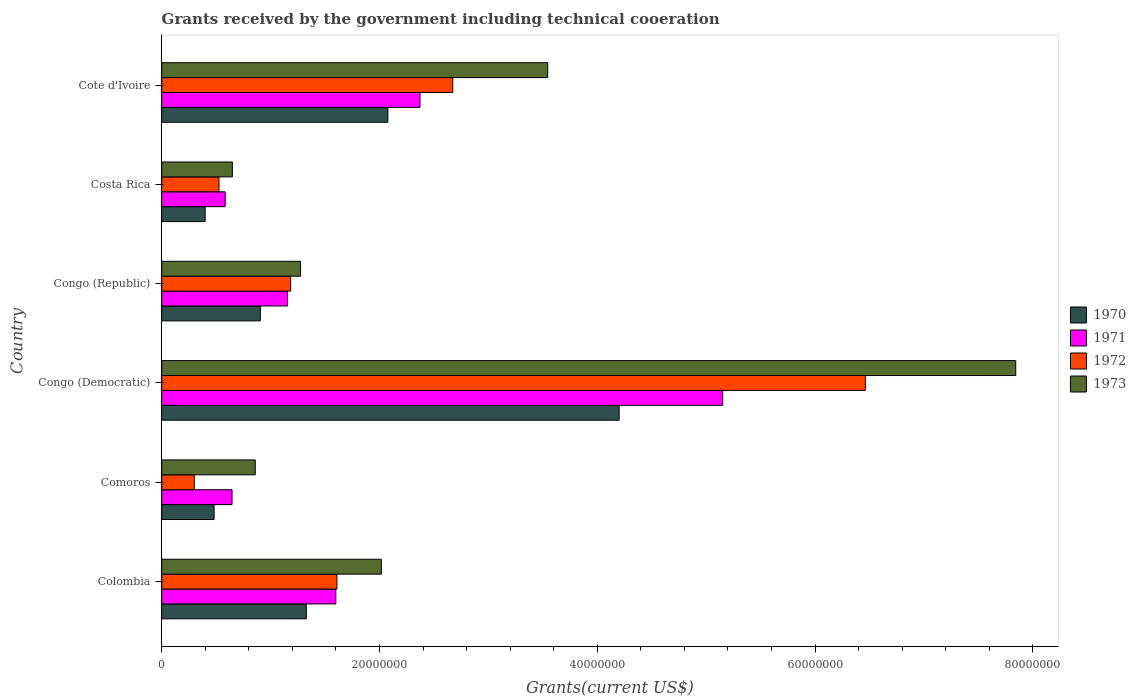How many groups of bars are there?
Keep it short and to the point. 6. How many bars are there on the 5th tick from the bottom?
Provide a short and direct response. 4. What is the label of the 5th group of bars from the top?
Ensure brevity in your answer.  Comoros. What is the total grants received by the government in 1971 in Congo (Republic)?
Provide a short and direct response. 1.16e+07. Across all countries, what is the maximum total grants received by the government in 1971?
Make the answer very short. 5.15e+07. Across all countries, what is the minimum total grants received by the government in 1972?
Make the answer very short. 2.99e+06. In which country was the total grants received by the government in 1970 maximum?
Ensure brevity in your answer.  Congo (Democratic). In which country was the total grants received by the government in 1970 minimum?
Offer a very short reply. Costa Rica. What is the total total grants received by the government in 1971 in the graph?
Your answer should be compact. 1.15e+08. What is the difference between the total grants received by the government in 1973 in Comoros and that in Cote d'Ivoire?
Provide a short and direct response. -2.69e+07. What is the difference between the total grants received by the government in 1972 in Comoros and the total grants received by the government in 1971 in Costa Rica?
Your answer should be compact. -2.84e+06. What is the average total grants received by the government in 1970 per country?
Provide a succinct answer. 1.57e+07. What is the difference between the total grants received by the government in 1973 and total grants received by the government in 1972 in Congo (Democratic)?
Your answer should be compact. 1.38e+07. What is the ratio of the total grants received by the government in 1971 in Congo (Democratic) to that in Congo (Republic)?
Your answer should be compact. 4.46. Is the total grants received by the government in 1972 in Congo (Democratic) less than that in Cote d'Ivoire?
Keep it short and to the point. No. What is the difference between the highest and the second highest total grants received by the government in 1973?
Offer a terse response. 4.30e+07. What is the difference between the highest and the lowest total grants received by the government in 1971?
Your response must be concise. 4.57e+07. Is the sum of the total grants received by the government in 1973 in Costa Rica and Cote d'Ivoire greater than the maximum total grants received by the government in 1971 across all countries?
Your response must be concise. No. Is it the case that in every country, the sum of the total grants received by the government in 1973 and total grants received by the government in 1970 is greater than the sum of total grants received by the government in 1972 and total grants received by the government in 1971?
Make the answer very short. No. What does the 2nd bar from the bottom in Costa Rica represents?
Offer a terse response. 1971. Are all the bars in the graph horizontal?
Your response must be concise. Yes. What is the difference between two consecutive major ticks on the X-axis?
Make the answer very short. 2.00e+07. Does the graph contain grids?
Provide a short and direct response. No. Where does the legend appear in the graph?
Your response must be concise. Center right. What is the title of the graph?
Your response must be concise. Grants received by the government including technical cooeration. Does "1991" appear as one of the legend labels in the graph?
Your answer should be compact. No. What is the label or title of the X-axis?
Your answer should be compact. Grants(current US$). What is the label or title of the Y-axis?
Ensure brevity in your answer.  Country. What is the Grants(current US$) of 1970 in Colombia?
Make the answer very short. 1.33e+07. What is the Grants(current US$) in 1971 in Colombia?
Provide a short and direct response. 1.60e+07. What is the Grants(current US$) in 1972 in Colombia?
Offer a very short reply. 1.61e+07. What is the Grants(current US$) in 1973 in Colombia?
Provide a short and direct response. 2.02e+07. What is the Grants(current US$) of 1970 in Comoros?
Your answer should be compact. 4.81e+06. What is the Grants(current US$) in 1971 in Comoros?
Give a very brief answer. 6.46e+06. What is the Grants(current US$) of 1972 in Comoros?
Your answer should be very brief. 2.99e+06. What is the Grants(current US$) of 1973 in Comoros?
Your answer should be very brief. 8.59e+06. What is the Grants(current US$) in 1970 in Congo (Democratic)?
Your answer should be very brief. 4.20e+07. What is the Grants(current US$) in 1971 in Congo (Democratic)?
Provide a short and direct response. 5.15e+07. What is the Grants(current US$) in 1972 in Congo (Democratic)?
Give a very brief answer. 6.46e+07. What is the Grants(current US$) in 1973 in Congo (Democratic)?
Keep it short and to the point. 7.84e+07. What is the Grants(current US$) of 1970 in Congo (Republic)?
Your answer should be compact. 9.06e+06. What is the Grants(current US$) in 1971 in Congo (Republic)?
Your answer should be very brief. 1.16e+07. What is the Grants(current US$) of 1972 in Congo (Republic)?
Your answer should be very brief. 1.18e+07. What is the Grants(current US$) of 1973 in Congo (Republic)?
Make the answer very short. 1.28e+07. What is the Grants(current US$) of 1970 in Costa Rica?
Give a very brief answer. 3.99e+06. What is the Grants(current US$) of 1971 in Costa Rica?
Give a very brief answer. 5.83e+06. What is the Grants(current US$) of 1972 in Costa Rica?
Keep it short and to the point. 5.26e+06. What is the Grants(current US$) in 1973 in Costa Rica?
Make the answer very short. 6.49e+06. What is the Grants(current US$) of 1970 in Cote d'Ivoire?
Make the answer very short. 2.08e+07. What is the Grants(current US$) in 1971 in Cote d'Ivoire?
Provide a succinct answer. 2.37e+07. What is the Grants(current US$) of 1972 in Cote d'Ivoire?
Provide a short and direct response. 2.67e+07. What is the Grants(current US$) in 1973 in Cote d'Ivoire?
Your response must be concise. 3.54e+07. Across all countries, what is the maximum Grants(current US$) in 1970?
Give a very brief answer. 4.20e+07. Across all countries, what is the maximum Grants(current US$) of 1971?
Make the answer very short. 5.15e+07. Across all countries, what is the maximum Grants(current US$) in 1972?
Offer a terse response. 6.46e+07. Across all countries, what is the maximum Grants(current US$) of 1973?
Offer a terse response. 7.84e+07. Across all countries, what is the minimum Grants(current US$) in 1970?
Keep it short and to the point. 3.99e+06. Across all countries, what is the minimum Grants(current US$) in 1971?
Your response must be concise. 5.83e+06. Across all countries, what is the minimum Grants(current US$) in 1972?
Provide a short and direct response. 2.99e+06. Across all countries, what is the minimum Grants(current US$) in 1973?
Give a very brief answer. 6.49e+06. What is the total Grants(current US$) of 1970 in the graph?
Your response must be concise. 9.39e+07. What is the total Grants(current US$) in 1971 in the graph?
Your answer should be compact. 1.15e+08. What is the total Grants(current US$) of 1972 in the graph?
Keep it short and to the point. 1.28e+08. What is the total Grants(current US$) in 1973 in the graph?
Keep it short and to the point. 1.62e+08. What is the difference between the Grants(current US$) in 1970 in Colombia and that in Comoros?
Ensure brevity in your answer.  8.47e+06. What is the difference between the Grants(current US$) in 1971 in Colombia and that in Comoros?
Keep it short and to the point. 9.53e+06. What is the difference between the Grants(current US$) of 1972 in Colombia and that in Comoros?
Your answer should be compact. 1.31e+07. What is the difference between the Grants(current US$) in 1973 in Colombia and that in Comoros?
Your response must be concise. 1.16e+07. What is the difference between the Grants(current US$) of 1970 in Colombia and that in Congo (Democratic)?
Your answer should be very brief. -2.87e+07. What is the difference between the Grants(current US$) in 1971 in Colombia and that in Congo (Democratic)?
Ensure brevity in your answer.  -3.55e+07. What is the difference between the Grants(current US$) in 1972 in Colombia and that in Congo (Democratic)?
Make the answer very short. -4.85e+07. What is the difference between the Grants(current US$) of 1973 in Colombia and that in Congo (Democratic)?
Your answer should be compact. -5.83e+07. What is the difference between the Grants(current US$) of 1970 in Colombia and that in Congo (Republic)?
Ensure brevity in your answer.  4.22e+06. What is the difference between the Grants(current US$) in 1971 in Colombia and that in Congo (Republic)?
Ensure brevity in your answer.  4.44e+06. What is the difference between the Grants(current US$) in 1972 in Colombia and that in Congo (Republic)?
Provide a short and direct response. 4.25e+06. What is the difference between the Grants(current US$) in 1973 in Colombia and that in Congo (Republic)?
Provide a succinct answer. 7.42e+06. What is the difference between the Grants(current US$) of 1970 in Colombia and that in Costa Rica?
Your response must be concise. 9.29e+06. What is the difference between the Grants(current US$) of 1971 in Colombia and that in Costa Rica?
Your response must be concise. 1.02e+07. What is the difference between the Grants(current US$) in 1972 in Colombia and that in Costa Rica?
Provide a succinct answer. 1.08e+07. What is the difference between the Grants(current US$) in 1973 in Colombia and that in Costa Rica?
Ensure brevity in your answer.  1.37e+07. What is the difference between the Grants(current US$) of 1970 in Colombia and that in Cote d'Ivoire?
Your response must be concise. -7.49e+06. What is the difference between the Grants(current US$) of 1971 in Colombia and that in Cote d'Ivoire?
Your response must be concise. -7.73e+06. What is the difference between the Grants(current US$) of 1972 in Colombia and that in Cote d'Ivoire?
Your answer should be compact. -1.06e+07. What is the difference between the Grants(current US$) of 1973 in Colombia and that in Cote d'Ivoire?
Provide a succinct answer. -1.53e+07. What is the difference between the Grants(current US$) in 1970 in Comoros and that in Congo (Democratic)?
Ensure brevity in your answer.  -3.72e+07. What is the difference between the Grants(current US$) in 1971 in Comoros and that in Congo (Democratic)?
Provide a succinct answer. -4.51e+07. What is the difference between the Grants(current US$) in 1972 in Comoros and that in Congo (Democratic)?
Offer a very short reply. -6.16e+07. What is the difference between the Grants(current US$) in 1973 in Comoros and that in Congo (Democratic)?
Offer a terse response. -6.98e+07. What is the difference between the Grants(current US$) of 1970 in Comoros and that in Congo (Republic)?
Make the answer very short. -4.25e+06. What is the difference between the Grants(current US$) of 1971 in Comoros and that in Congo (Republic)?
Your answer should be compact. -5.09e+06. What is the difference between the Grants(current US$) in 1972 in Comoros and that in Congo (Republic)?
Provide a short and direct response. -8.85e+06. What is the difference between the Grants(current US$) of 1973 in Comoros and that in Congo (Republic)?
Make the answer very short. -4.16e+06. What is the difference between the Grants(current US$) of 1970 in Comoros and that in Costa Rica?
Make the answer very short. 8.20e+05. What is the difference between the Grants(current US$) of 1971 in Comoros and that in Costa Rica?
Ensure brevity in your answer.  6.30e+05. What is the difference between the Grants(current US$) of 1972 in Comoros and that in Costa Rica?
Ensure brevity in your answer.  -2.27e+06. What is the difference between the Grants(current US$) of 1973 in Comoros and that in Costa Rica?
Your response must be concise. 2.10e+06. What is the difference between the Grants(current US$) in 1970 in Comoros and that in Cote d'Ivoire?
Offer a very short reply. -1.60e+07. What is the difference between the Grants(current US$) of 1971 in Comoros and that in Cote d'Ivoire?
Give a very brief answer. -1.73e+07. What is the difference between the Grants(current US$) of 1972 in Comoros and that in Cote d'Ivoire?
Ensure brevity in your answer.  -2.37e+07. What is the difference between the Grants(current US$) in 1973 in Comoros and that in Cote d'Ivoire?
Provide a succinct answer. -2.69e+07. What is the difference between the Grants(current US$) of 1970 in Congo (Democratic) and that in Congo (Republic)?
Offer a terse response. 3.30e+07. What is the difference between the Grants(current US$) of 1971 in Congo (Democratic) and that in Congo (Republic)?
Your answer should be very brief. 4.00e+07. What is the difference between the Grants(current US$) of 1972 in Congo (Democratic) and that in Congo (Republic)?
Give a very brief answer. 5.28e+07. What is the difference between the Grants(current US$) of 1973 in Congo (Democratic) and that in Congo (Republic)?
Offer a very short reply. 6.57e+07. What is the difference between the Grants(current US$) of 1970 in Congo (Democratic) and that in Costa Rica?
Keep it short and to the point. 3.80e+07. What is the difference between the Grants(current US$) in 1971 in Congo (Democratic) and that in Costa Rica?
Provide a succinct answer. 4.57e+07. What is the difference between the Grants(current US$) in 1972 in Congo (Democratic) and that in Costa Rica?
Your response must be concise. 5.94e+07. What is the difference between the Grants(current US$) in 1973 in Congo (Democratic) and that in Costa Rica?
Ensure brevity in your answer.  7.19e+07. What is the difference between the Grants(current US$) of 1970 in Congo (Democratic) and that in Cote d'Ivoire?
Keep it short and to the point. 2.12e+07. What is the difference between the Grants(current US$) in 1971 in Congo (Democratic) and that in Cote d'Ivoire?
Ensure brevity in your answer.  2.78e+07. What is the difference between the Grants(current US$) in 1972 in Congo (Democratic) and that in Cote d'Ivoire?
Your answer should be compact. 3.79e+07. What is the difference between the Grants(current US$) in 1973 in Congo (Democratic) and that in Cote d'Ivoire?
Ensure brevity in your answer.  4.30e+07. What is the difference between the Grants(current US$) of 1970 in Congo (Republic) and that in Costa Rica?
Make the answer very short. 5.07e+06. What is the difference between the Grants(current US$) of 1971 in Congo (Republic) and that in Costa Rica?
Provide a short and direct response. 5.72e+06. What is the difference between the Grants(current US$) of 1972 in Congo (Republic) and that in Costa Rica?
Your answer should be very brief. 6.58e+06. What is the difference between the Grants(current US$) in 1973 in Congo (Republic) and that in Costa Rica?
Offer a terse response. 6.26e+06. What is the difference between the Grants(current US$) of 1970 in Congo (Republic) and that in Cote d'Ivoire?
Your answer should be compact. -1.17e+07. What is the difference between the Grants(current US$) in 1971 in Congo (Republic) and that in Cote d'Ivoire?
Make the answer very short. -1.22e+07. What is the difference between the Grants(current US$) of 1972 in Congo (Republic) and that in Cote d'Ivoire?
Make the answer very short. -1.49e+07. What is the difference between the Grants(current US$) in 1973 in Congo (Republic) and that in Cote d'Ivoire?
Your answer should be very brief. -2.27e+07. What is the difference between the Grants(current US$) in 1970 in Costa Rica and that in Cote d'Ivoire?
Your answer should be very brief. -1.68e+07. What is the difference between the Grants(current US$) in 1971 in Costa Rica and that in Cote d'Ivoire?
Make the answer very short. -1.79e+07. What is the difference between the Grants(current US$) of 1972 in Costa Rica and that in Cote d'Ivoire?
Keep it short and to the point. -2.15e+07. What is the difference between the Grants(current US$) in 1973 in Costa Rica and that in Cote d'Ivoire?
Your response must be concise. -2.90e+07. What is the difference between the Grants(current US$) of 1970 in Colombia and the Grants(current US$) of 1971 in Comoros?
Keep it short and to the point. 6.82e+06. What is the difference between the Grants(current US$) of 1970 in Colombia and the Grants(current US$) of 1972 in Comoros?
Give a very brief answer. 1.03e+07. What is the difference between the Grants(current US$) of 1970 in Colombia and the Grants(current US$) of 1973 in Comoros?
Your answer should be very brief. 4.69e+06. What is the difference between the Grants(current US$) in 1971 in Colombia and the Grants(current US$) in 1972 in Comoros?
Your answer should be compact. 1.30e+07. What is the difference between the Grants(current US$) in 1971 in Colombia and the Grants(current US$) in 1973 in Comoros?
Keep it short and to the point. 7.40e+06. What is the difference between the Grants(current US$) of 1972 in Colombia and the Grants(current US$) of 1973 in Comoros?
Ensure brevity in your answer.  7.50e+06. What is the difference between the Grants(current US$) in 1970 in Colombia and the Grants(current US$) in 1971 in Congo (Democratic)?
Your answer should be compact. -3.82e+07. What is the difference between the Grants(current US$) of 1970 in Colombia and the Grants(current US$) of 1972 in Congo (Democratic)?
Your answer should be very brief. -5.13e+07. What is the difference between the Grants(current US$) in 1970 in Colombia and the Grants(current US$) in 1973 in Congo (Democratic)?
Offer a very short reply. -6.52e+07. What is the difference between the Grants(current US$) in 1971 in Colombia and the Grants(current US$) in 1972 in Congo (Democratic)?
Your response must be concise. -4.86e+07. What is the difference between the Grants(current US$) in 1971 in Colombia and the Grants(current US$) in 1973 in Congo (Democratic)?
Give a very brief answer. -6.24e+07. What is the difference between the Grants(current US$) in 1972 in Colombia and the Grants(current US$) in 1973 in Congo (Democratic)?
Provide a succinct answer. -6.23e+07. What is the difference between the Grants(current US$) of 1970 in Colombia and the Grants(current US$) of 1971 in Congo (Republic)?
Offer a terse response. 1.73e+06. What is the difference between the Grants(current US$) of 1970 in Colombia and the Grants(current US$) of 1972 in Congo (Republic)?
Provide a short and direct response. 1.44e+06. What is the difference between the Grants(current US$) in 1970 in Colombia and the Grants(current US$) in 1973 in Congo (Republic)?
Offer a very short reply. 5.30e+05. What is the difference between the Grants(current US$) of 1971 in Colombia and the Grants(current US$) of 1972 in Congo (Republic)?
Provide a succinct answer. 4.15e+06. What is the difference between the Grants(current US$) of 1971 in Colombia and the Grants(current US$) of 1973 in Congo (Republic)?
Provide a succinct answer. 3.24e+06. What is the difference between the Grants(current US$) in 1972 in Colombia and the Grants(current US$) in 1973 in Congo (Republic)?
Provide a short and direct response. 3.34e+06. What is the difference between the Grants(current US$) in 1970 in Colombia and the Grants(current US$) in 1971 in Costa Rica?
Offer a very short reply. 7.45e+06. What is the difference between the Grants(current US$) of 1970 in Colombia and the Grants(current US$) of 1972 in Costa Rica?
Offer a terse response. 8.02e+06. What is the difference between the Grants(current US$) of 1970 in Colombia and the Grants(current US$) of 1973 in Costa Rica?
Your answer should be very brief. 6.79e+06. What is the difference between the Grants(current US$) of 1971 in Colombia and the Grants(current US$) of 1972 in Costa Rica?
Provide a succinct answer. 1.07e+07. What is the difference between the Grants(current US$) in 1971 in Colombia and the Grants(current US$) in 1973 in Costa Rica?
Your answer should be compact. 9.50e+06. What is the difference between the Grants(current US$) in 1972 in Colombia and the Grants(current US$) in 1973 in Costa Rica?
Make the answer very short. 9.60e+06. What is the difference between the Grants(current US$) of 1970 in Colombia and the Grants(current US$) of 1971 in Cote d'Ivoire?
Keep it short and to the point. -1.04e+07. What is the difference between the Grants(current US$) of 1970 in Colombia and the Grants(current US$) of 1972 in Cote d'Ivoire?
Make the answer very short. -1.34e+07. What is the difference between the Grants(current US$) of 1970 in Colombia and the Grants(current US$) of 1973 in Cote d'Ivoire?
Provide a succinct answer. -2.22e+07. What is the difference between the Grants(current US$) of 1971 in Colombia and the Grants(current US$) of 1972 in Cote d'Ivoire?
Provide a short and direct response. -1.07e+07. What is the difference between the Grants(current US$) of 1971 in Colombia and the Grants(current US$) of 1973 in Cote d'Ivoire?
Provide a succinct answer. -1.95e+07. What is the difference between the Grants(current US$) in 1972 in Colombia and the Grants(current US$) in 1973 in Cote d'Ivoire?
Your answer should be compact. -1.94e+07. What is the difference between the Grants(current US$) in 1970 in Comoros and the Grants(current US$) in 1971 in Congo (Democratic)?
Your answer should be compact. -4.67e+07. What is the difference between the Grants(current US$) in 1970 in Comoros and the Grants(current US$) in 1972 in Congo (Democratic)?
Offer a terse response. -5.98e+07. What is the difference between the Grants(current US$) in 1970 in Comoros and the Grants(current US$) in 1973 in Congo (Democratic)?
Offer a very short reply. -7.36e+07. What is the difference between the Grants(current US$) of 1971 in Comoros and the Grants(current US$) of 1972 in Congo (Democratic)?
Provide a short and direct response. -5.82e+07. What is the difference between the Grants(current US$) in 1971 in Comoros and the Grants(current US$) in 1973 in Congo (Democratic)?
Your answer should be very brief. -7.20e+07. What is the difference between the Grants(current US$) in 1972 in Comoros and the Grants(current US$) in 1973 in Congo (Democratic)?
Your response must be concise. -7.54e+07. What is the difference between the Grants(current US$) of 1970 in Comoros and the Grants(current US$) of 1971 in Congo (Republic)?
Offer a terse response. -6.74e+06. What is the difference between the Grants(current US$) of 1970 in Comoros and the Grants(current US$) of 1972 in Congo (Republic)?
Your answer should be compact. -7.03e+06. What is the difference between the Grants(current US$) in 1970 in Comoros and the Grants(current US$) in 1973 in Congo (Republic)?
Offer a very short reply. -7.94e+06. What is the difference between the Grants(current US$) of 1971 in Comoros and the Grants(current US$) of 1972 in Congo (Republic)?
Ensure brevity in your answer.  -5.38e+06. What is the difference between the Grants(current US$) in 1971 in Comoros and the Grants(current US$) in 1973 in Congo (Republic)?
Provide a succinct answer. -6.29e+06. What is the difference between the Grants(current US$) in 1972 in Comoros and the Grants(current US$) in 1973 in Congo (Republic)?
Provide a succinct answer. -9.76e+06. What is the difference between the Grants(current US$) of 1970 in Comoros and the Grants(current US$) of 1971 in Costa Rica?
Offer a very short reply. -1.02e+06. What is the difference between the Grants(current US$) of 1970 in Comoros and the Grants(current US$) of 1972 in Costa Rica?
Provide a short and direct response. -4.50e+05. What is the difference between the Grants(current US$) of 1970 in Comoros and the Grants(current US$) of 1973 in Costa Rica?
Ensure brevity in your answer.  -1.68e+06. What is the difference between the Grants(current US$) of 1971 in Comoros and the Grants(current US$) of 1972 in Costa Rica?
Provide a succinct answer. 1.20e+06. What is the difference between the Grants(current US$) of 1972 in Comoros and the Grants(current US$) of 1973 in Costa Rica?
Your response must be concise. -3.50e+06. What is the difference between the Grants(current US$) in 1970 in Comoros and the Grants(current US$) in 1971 in Cote d'Ivoire?
Ensure brevity in your answer.  -1.89e+07. What is the difference between the Grants(current US$) of 1970 in Comoros and the Grants(current US$) of 1972 in Cote d'Ivoire?
Your response must be concise. -2.19e+07. What is the difference between the Grants(current US$) of 1970 in Comoros and the Grants(current US$) of 1973 in Cote d'Ivoire?
Keep it short and to the point. -3.06e+07. What is the difference between the Grants(current US$) in 1971 in Comoros and the Grants(current US$) in 1972 in Cote d'Ivoire?
Ensure brevity in your answer.  -2.03e+07. What is the difference between the Grants(current US$) of 1971 in Comoros and the Grants(current US$) of 1973 in Cote d'Ivoire?
Provide a succinct answer. -2.90e+07. What is the difference between the Grants(current US$) of 1972 in Comoros and the Grants(current US$) of 1973 in Cote d'Ivoire?
Your response must be concise. -3.25e+07. What is the difference between the Grants(current US$) in 1970 in Congo (Democratic) and the Grants(current US$) in 1971 in Congo (Republic)?
Ensure brevity in your answer.  3.05e+07. What is the difference between the Grants(current US$) of 1970 in Congo (Democratic) and the Grants(current US$) of 1972 in Congo (Republic)?
Your answer should be compact. 3.02e+07. What is the difference between the Grants(current US$) of 1970 in Congo (Democratic) and the Grants(current US$) of 1973 in Congo (Republic)?
Your answer should be compact. 2.93e+07. What is the difference between the Grants(current US$) in 1971 in Congo (Democratic) and the Grants(current US$) in 1972 in Congo (Republic)?
Make the answer very short. 3.97e+07. What is the difference between the Grants(current US$) in 1971 in Congo (Democratic) and the Grants(current US$) in 1973 in Congo (Republic)?
Keep it short and to the point. 3.88e+07. What is the difference between the Grants(current US$) in 1972 in Congo (Democratic) and the Grants(current US$) in 1973 in Congo (Republic)?
Provide a succinct answer. 5.19e+07. What is the difference between the Grants(current US$) in 1970 in Congo (Democratic) and the Grants(current US$) in 1971 in Costa Rica?
Offer a very short reply. 3.62e+07. What is the difference between the Grants(current US$) in 1970 in Congo (Democratic) and the Grants(current US$) in 1972 in Costa Rica?
Offer a terse response. 3.68e+07. What is the difference between the Grants(current US$) in 1970 in Congo (Democratic) and the Grants(current US$) in 1973 in Costa Rica?
Your response must be concise. 3.55e+07. What is the difference between the Grants(current US$) in 1971 in Congo (Democratic) and the Grants(current US$) in 1972 in Costa Rica?
Offer a very short reply. 4.63e+07. What is the difference between the Grants(current US$) of 1971 in Congo (Democratic) and the Grants(current US$) of 1973 in Costa Rica?
Offer a terse response. 4.50e+07. What is the difference between the Grants(current US$) in 1972 in Congo (Democratic) and the Grants(current US$) in 1973 in Costa Rica?
Make the answer very short. 5.81e+07. What is the difference between the Grants(current US$) in 1970 in Congo (Democratic) and the Grants(current US$) in 1971 in Cote d'Ivoire?
Your answer should be compact. 1.83e+07. What is the difference between the Grants(current US$) of 1970 in Congo (Democratic) and the Grants(current US$) of 1972 in Cote d'Ivoire?
Offer a terse response. 1.53e+07. What is the difference between the Grants(current US$) of 1970 in Congo (Democratic) and the Grants(current US$) of 1973 in Cote d'Ivoire?
Your answer should be compact. 6.56e+06. What is the difference between the Grants(current US$) of 1971 in Congo (Democratic) and the Grants(current US$) of 1972 in Cote d'Ivoire?
Give a very brief answer. 2.48e+07. What is the difference between the Grants(current US$) in 1971 in Congo (Democratic) and the Grants(current US$) in 1973 in Cote d'Ivoire?
Your response must be concise. 1.61e+07. What is the difference between the Grants(current US$) in 1972 in Congo (Democratic) and the Grants(current US$) in 1973 in Cote d'Ivoire?
Your answer should be very brief. 2.92e+07. What is the difference between the Grants(current US$) in 1970 in Congo (Republic) and the Grants(current US$) in 1971 in Costa Rica?
Make the answer very short. 3.23e+06. What is the difference between the Grants(current US$) in 1970 in Congo (Republic) and the Grants(current US$) in 1972 in Costa Rica?
Your answer should be compact. 3.80e+06. What is the difference between the Grants(current US$) of 1970 in Congo (Republic) and the Grants(current US$) of 1973 in Costa Rica?
Keep it short and to the point. 2.57e+06. What is the difference between the Grants(current US$) in 1971 in Congo (Republic) and the Grants(current US$) in 1972 in Costa Rica?
Offer a very short reply. 6.29e+06. What is the difference between the Grants(current US$) of 1971 in Congo (Republic) and the Grants(current US$) of 1973 in Costa Rica?
Provide a short and direct response. 5.06e+06. What is the difference between the Grants(current US$) in 1972 in Congo (Republic) and the Grants(current US$) in 1973 in Costa Rica?
Keep it short and to the point. 5.35e+06. What is the difference between the Grants(current US$) of 1970 in Congo (Republic) and the Grants(current US$) of 1971 in Cote d'Ivoire?
Give a very brief answer. -1.47e+07. What is the difference between the Grants(current US$) in 1970 in Congo (Republic) and the Grants(current US$) in 1972 in Cote d'Ivoire?
Ensure brevity in your answer.  -1.77e+07. What is the difference between the Grants(current US$) of 1970 in Congo (Republic) and the Grants(current US$) of 1973 in Cote d'Ivoire?
Ensure brevity in your answer.  -2.64e+07. What is the difference between the Grants(current US$) of 1971 in Congo (Republic) and the Grants(current US$) of 1972 in Cote d'Ivoire?
Provide a short and direct response. -1.52e+07. What is the difference between the Grants(current US$) of 1971 in Congo (Republic) and the Grants(current US$) of 1973 in Cote d'Ivoire?
Provide a succinct answer. -2.39e+07. What is the difference between the Grants(current US$) in 1972 in Congo (Republic) and the Grants(current US$) in 1973 in Cote d'Ivoire?
Your answer should be very brief. -2.36e+07. What is the difference between the Grants(current US$) in 1970 in Costa Rica and the Grants(current US$) in 1971 in Cote d'Ivoire?
Offer a terse response. -1.97e+07. What is the difference between the Grants(current US$) of 1970 in Costa Rica and the Grants(current US$) of 1972 in Cote d'Ivoire?
Provide a short and direct response. -2.27e+07. What is the difference between the Grants(current US$) in 1970 in Costa Rica and the Grants(current US$) in 1973 in Cote d'Ivoire?
Your response must be concise. -3.15e+07. What is the difference between the Grants(current US$) of 1971 in Costa Rica and the Grants(current US$) of 1972 in Cote d'Ivoire?
Ensure brevity in your answer.  -2.09e+07. What is the difference between the Grants(current US$) in 1971 in Costa Rica and the Grants(current US$) in 1973 in Cote d'Ivoire?
Offer a very short reply. -2.96e+07. What is the difference between the Grants(current US$) in 1972 in Costa Rica and the Grants(current US$) in 1973 in Cote d'Ivoire?
Keep it short and to the point. -3.02e+07. What is the average Grants(current US$) in 1970 per country?
Your answer should be compact. 1.57e+07. What is the average Grants(current US$) in 1971 per country?
Provide a succinct answer. 1.92e+07. What is the average Grants(current US$) in 1972 per country?
Your answer should be very brief. 2.13e+07. What is the average Grants(current US$) of 1973 per country?
Offer a very short reply. 2.70e+07. What is the difference between the Grants(current US$) of 1970 and Grants(current US$) of 1971 in Colombia?
Your answer should be compact. -2.71e+06. What is the difference between the Grants(current US$) in 1970 and Grants(current US$) in 1972 in Colombia?
Your answer should be compact. -2.81e+06. What is the difference between the Grants(current US$) in 1970 and Grants(current US$) in 1973 in Colombia?
Your response must be concise. -6.89e+06. What is the difference between the Grants(current US$) in 1971 and Grants(current US$) in 1973 in Colombia?
Offer a very short reply. -4.18e+06. What is the difference between the Grants(current US$) in 1972 and Grants(current US$) in 1973 in Colombia?
Make the answer very short. -4.08e+06. What is the difference between the Grants(current US$) of 1970 and Grants(current US$) of 1971 in Comoros?
Offer a very short reply. -1.65e+06. What is the difference between the Grants(current US$) in 1970 and Grants(current US$) in 1972 in Comoros?
Your answer should be very brief. 1.82e+06. What is the difference between the Grants(current US$) in 1970 and Grants(current US$) in 1973 in Comoros?
Your answer should be very brief. -3.78e+06. What is the difference between the Grants(current US$) in 1971 and Grants(current US$) in 1972 in Comoros?
Keep it short and to the point. 3.47e+06. What is the difference between the Grants(current US$) of 1971 and Grants(current US$) of 1973 in Comoros?
Provide a short and direct response. -2.13e+06. What is the difference between the Grants(current US$) in 1972 and Grants(current US$) in 1973 in Comoros?
Your answer should be very brief. -5.60e+06. What is the difference between the Grants(current US$) of 1970 and Grants(current US$) of 1971 in Congo (Democratic)?
Ensure brevity in your answer.  -9.51e+06. What is the difference between the Grants(current US$) in 1970 and Grants(current US$) in 1972 in Congo (Democratic)?
Offer a terse response. -2.26e+07. What is the difference between the Grants(current US$) of 1970 and Grants(current US$) of 1973 in Congo (Democratic)?
Offer a very short reply. -3.64e+07. What is the difference between the Grants(current US$) of 1971 and Grants(current US$) of 1972 in Congo (Democratic)?
Your response must be concise. -1.31e+07. What is the difference between the Grants(current US$) of 1971 and Grants(current US$) of 1973 in Congo (Democratic)?
Your answer should be compact. -2.69e+07. What is the difference between the Grants(current US$) of 1972 and Grants(current US$) of 1973 in Congo (Democratic)?
Provide a succinct answer. -1.38e+07. What is the difference between the Grants(current US$) of 1970 and Grants(current US$) of 1971 in Congo (Republic)?
Ensure brevity in your answer.  -2.49e+06. What is the difference between the Grants(current US$) of 1970 and Grants(current US$) of 1972 in Congo (Republic)?
Make the answer very short. -2.78e+06. What is the difference between the Grants(current US$) of 1970 and Grants(current US$) of 1973 in Congo (Republic)?
Your answer should be very brief. -3.69e+06. What is the difference between the Grants(current US$) in 1971 and Grants(current US$) in 1972 in Congo (Republic)?
Provide a succinct answer. -2.90e+05. What is the difference between the Grants(current US$) of 1971 and Grants(current US$) of 1973 in Congo (Republic)?
Your answer should be compact. -1.20e+06. What is the difference between the Grants(current US$) in 1972 and Grants(current US$) in 1973 in Congo (Republic)?
Make the answer very short. -9.10e+05. What is the difference between the Grants(current US$) in 1970 and Grants(current US$) in 1971 in Costa Rica?
Offer a very short reply. -1.84e+06. What is the difference between the Grants(current US$) in 1970 and Grants(current US$) in 1972 in Costa Rica?
Offer a very short reply. -1.27e+06. What is the difference between the Grants(current US$) in 1970 and Grants(current US$) in 1973 in Costa Rica?
Give a very brief answer. -2.50e+06. What is the difference between the Grants(current US$) in 1971 and Grants(current US$) in 1972 in Costa Rica?
Your answer should be compact. 5.70e+05. What is the difference between the Grants(current US$) in 1971 and Grants(current US$) in 1973 in Costa Rica?
Provide a short and direct response. -6.60e+05. What is the difference between the Grants(current US$) in 1972 and Grants(current US$) in 1973 in Costa Rica?
Provide a short and direct response. -1.23e+06. What is the difference between the Grants(current US$) of 1970 and Grants(current US$) of 1971 in Cote d'Ivoire?
Offer a terse response. -2.95e+06. What is the difference between the Grants(current US$) of 1970 and Grants(current US$) of 1972 in Cote d'Ivoire?
Offer a terse response. -5.96e+06. What is the difference between the Grants(current US$) in 1970 and Grants(current US$) in 1973 in Cote d'Ivoire?
Keep it short and to the point. -1.47e+07. What is the difference between the Grants(current US$) of 1971 and Grants(current US$) of 1972 in Cote d'Ivoire?
Provide a short and direct response. -3.01e+06. What is the difference between the Grants(current US$) of 1971 and Grants(current US$) of 1973 in Cote d'Ivoire?
Offer a very short reply. -1.17e+07. What is the difference between the Grants(current US$) in 1972 and Grants(current US$) in 1973 in Cote d'Ivoire?
Your response must be concise. -8.72e+06. What is the ratio of the Grants(current US$) of 1970 in Colombia to that in Comoros?
Provide a succinct answer. 2.76. What is the ratio of the Grants(current US$) in 1971 in Colombia to that in Comoros?
Give a very brief answer. 2.48. What is the ratio of the Grants(current US$) of 1972 in Colombia to that in Comoros?
Give a very brief answer. 5.38. What is the ratio of the Grants(current US$) of 1973 in Colombia to that in Comoros?
Ensure brevity in your answer.  2.35. What is the ratio of the Grants(current US$) in 1970 in Colombia to that in Congo (Democratic)?
Offer a very short reply. 0.32. What is the ratio of the Grants(current US$) of 1971 in Colombia to that in Congo (Democratic)?
Offer a very short reply. 0.31. What is the ratio of the Grants(current US$) of 1972 in Colombia to that in Congo (Democratic)?
Make the answer very short. 0.25. What is the ratio of the Grants(current US$) in 1973 in Colombia to that in Congo (Democratic)?
Provide a succinct answer. 0.26. What is the ratio of the Grants(current US$) of 1970 in Colombia to that in Congo (Republic)?
Your response must be concise. 1.47. What is the ratio of the Grants(current US$) of 1971 in Colombia to that in Congo (Republic)?
Keep it short and to the point. 1.38. What is the ratio of the Grants(current US$) in 1972 in Colombia to that in Congo (Republic)?
Offer a very short reply. 1.36. What is the ratio of the Grants(current US$) in 1973 in Colombia to that in Congo (Republic)?
Offer a very short reply. 1.58. What is the ratio of the Grants(current US$) in 1970 in Colombia to that in Costa Rica?
Offer a very short reply. 3.33. What is the ratio of the Grants(current US$) of 1971 in Colombia to that in Costa Rica?
Offer a terse response. 2.74. What is the ratio of the Grants(current US$) of 1972 in Colombia to that in Costa Rica?
Provide a short and direct response. 3.06. What is the ratio of the Grants(current US$) in 1973 in Colombia to that in Costa Rica?
Offer a terse response. 3.11. What is the ratio of the Grants(current US$) in 1970 in Colombia to that in Cote d'Ivoire?
Your answer should be compact. 0.64. What is the ratio of the Grants(current US$) in 1971 in Colombia to that in Cote d'Ivoire?
Give a very brief answer. 0.67. What is the ratio of the Grants(current US$) in 1972 in Colombia to that in Cote d'Ivoire?
Your answer should be compact. 0.6. What is the ratio of the Grants(current US$) of 1973 in Colombia to that in Cote d'Ivoire?
Your answer should be compact. 0.57. What is the ratio of the Grants(current US$) in 1970 in Comoros to that in Congo (Democratic)?
Offer a very short reply. 0.11. What is the ratio of the Grants(current US$) in 1971 in Comoros to that in Congo (Democratic)?
Provide a succinct answer. 0.13. What is the ratio of the Grants(current US$) in 1972 in Comoros to that in Congo (Democratic)?
Provide a succinct answer. 0.05. What is the ratio of the Grants(current US$) in 1973 in Comoros to that in Congo (Democratic)?
Provide a short and direct response. 0.11. What is the ratio of the Grants(current US$) in 1970 in Comoros to that in Congo (Republic)?
Your answer should be very brief. 0.53. What is the ratio of the Grants(current US$) of 1971 in Comoros to that in Congo (Republic)?
Provide a succinct answer. 0.56. What is the ratio of the Grants(current US$) in 1972 in Comoros to that in Congo (Republic)?
Provide a short and direct response. 0.25. What is the ratio of the Grants(current US$) of 1973 in Comoros to that in Congo (Republic)?
Your answer should be very brief. 0.67. What is the ratio of the Grants(current US$) of 1970 in Comoros to that in Costa Rica?
Ensure brevity in your answer.  1.21. What is the ratio of the Grants(current US$) of 1971 in Comoros to that in Costa Rica?
Ensure brevity in your answer.  1.11. What is the ratio of the Grants(current US$) in 1972 in Comoros to that in Costa Rica?
Make the answer very short. 0.57. What is the ratio of the Grants(current US$) of 1973 in Comoros to that in Costa Rica?
Offer a terse response. 1.32. What is the ratio of the Grants(current US$) in 1970 in Comoros to that in Cote d'Ivoire?
Your response must be concise. 0.23. What is the ratio of the Grants(current US$) in 1971 in Comoros to that in Cote d'Ivoire?
Keep it short and to the point. 0.27. What is the ratio of the Grants(current US$) in 1972 in Comoros to that in Cote d'Ivoire?
Make the answer very short. 0.11. What is the ratio of the Grants(current US$) of 1973 in Comoros to that in Cote d'Ivoire?
Give a very brief answer. 0.24. What is the ratio of the Grants(current US$) in 1970 in Congo (Democratic) to that in Congo (Republic)?
Make the answer very short. 4.64. What is the ratio of the Grants(current US$) in 1971 in Congo (Democratic) to that in Congo (Republic)?
Your answer should be compact. 4.46. What is the ratio of the Grants(current US$) of 1972 in Congo (Democratic) to that in Congo (Republic)?
Ensure brevity in your answer.  5.46. What is the ratio of the Grants(current US$) in 1973 in Congo (Democratic) to that in Congo (Republic)?
Provide a short and direct response. 6.15. What is the ratio of the Grants(current US$) of 1970 in Congo (Democratic) to that in Costa Rica?
Your response must be concise. 10.53. What is the ratio of the Grants(current US$) in 1971 in Congo (Democratic) to that in Costa Rica?
Give a very brief answer. 8.84. What is the ratio of the Grants(current US$) of 1972 in Congo (Democratic) to that in Costa Rica?
Your answer should be compact. 12.29. What is the ratio of the Grants(current US$) in 1973 in Congo (Democratic) to that in Costa Rica?
Your response must be concise. 12.08. What is the ratio of the Grants(current US$) of 1970 in Congo (Democratic) to that in Cote d'Ivoire?
Ensure brevity in your answer.  2.02. What is the ratio of the Grants(current US$) in 1971 in Congo (Democratic) to that in Cote d'Ivoire?
Offer a very short reply. 2.17. What is the ratio of the Grants(current US$) of 1972 in Congo (Democratic) to that in Cote d'Ivoire?
Offer a terse response. 2.42. What is the ratio of the Grants(current US$) of 1973 in Congo (Democratic) to that in Cote d'Ivoire?
Provide a short and direct response. 2.21. What is the ratio of the Grants(current US$) in 1970 in Congo (Republic) to that in Costa Rica?
Your response must be concise. 2.27. What is the ratio of the Grants(current US$) of 1971 in Congo (Republic) to that in Costa Rica?
Provide a short and direct response. 1.98. What is the ratio of the Grants(current US$) in 1972 in Congo (Republic) to that in Costa Rica?
Offer a very short reply. 2.25. What is the ratio of the Grants(current US$) in 1973 in Congo (Republic) to that in Costa Rica?
Offer a very short reply. 1.96. What is the ratio of the Grants(current US$) of 1970 in Congo (Republic) to that in Cote d'Ivoire?
Offer a terse response. 0.44. What is the ratio of the Grants(current US$) in 1971 in Congo (Republic) to that in Cote d'Ivoire?
Keep it short and to the point. 0.49. What is the ratio of the Grants(current US$) in 1972 in Congo (Republic) to that in Cote d'Ivoire?
Keep it short and to the point. 0.44. What is the ratio of the Grants(current US$) in 1973 in Congo (Republic) to that in Cote d'Ivoire?
Your answer should be compact. 0.36. What is the ratio of the Grants(current US$) in 1970 in Costa Rica to that in Cote d'Ivoire?
Keep it short and to the point. 0.19. What is the ratio of the Grants(current US$) of 1971 in Costa Rica to that in Cote d'Ivoire?
Keep it short and to the point. 0.25. What is the ratio of the Grants(current US$) in 1972 in Costa Rica to that in Cote d'Ivoire?
Your response must be concise. 0.2. What is the ratio of the Grants(current US$) of 1973 in Costa Rica to that in Cote d'Ivoire?
Your response must be concise. 0.18. What is the difference between the highest and the second highest Grants(current US$) in 1970?
Your answer should be very brief. 2.12e+07. What is the difference between the highest and the second highest Grants(current US$) of 1971?
Make the answer very short. 2.78e+07. What is the difference between the highest and the second highest Grants(current US$) of 1972?
Offer a very short reply. 3.79e+07. What is the difference between the highest and the second highest Grants(current US$) in 1973?
Your answer should be compact. 4.30e+07. What is the difference between the highest and the lowest Grants(current US$) of 1970?
Your response must be concise. 3.80e+07. What is the difference between the highest and the lowest Grants(current US$) in 1971?
Your answer should be compact. 4.57e+07. What is the difference between the highest and the lowest Grants(current US$) in 1972?
Give a very brief answer. 6.16e+07. What is the difference between the highest and the lowest Grants(current US$) in 1973?
Provide a short and direct response. 7.19e+07. 